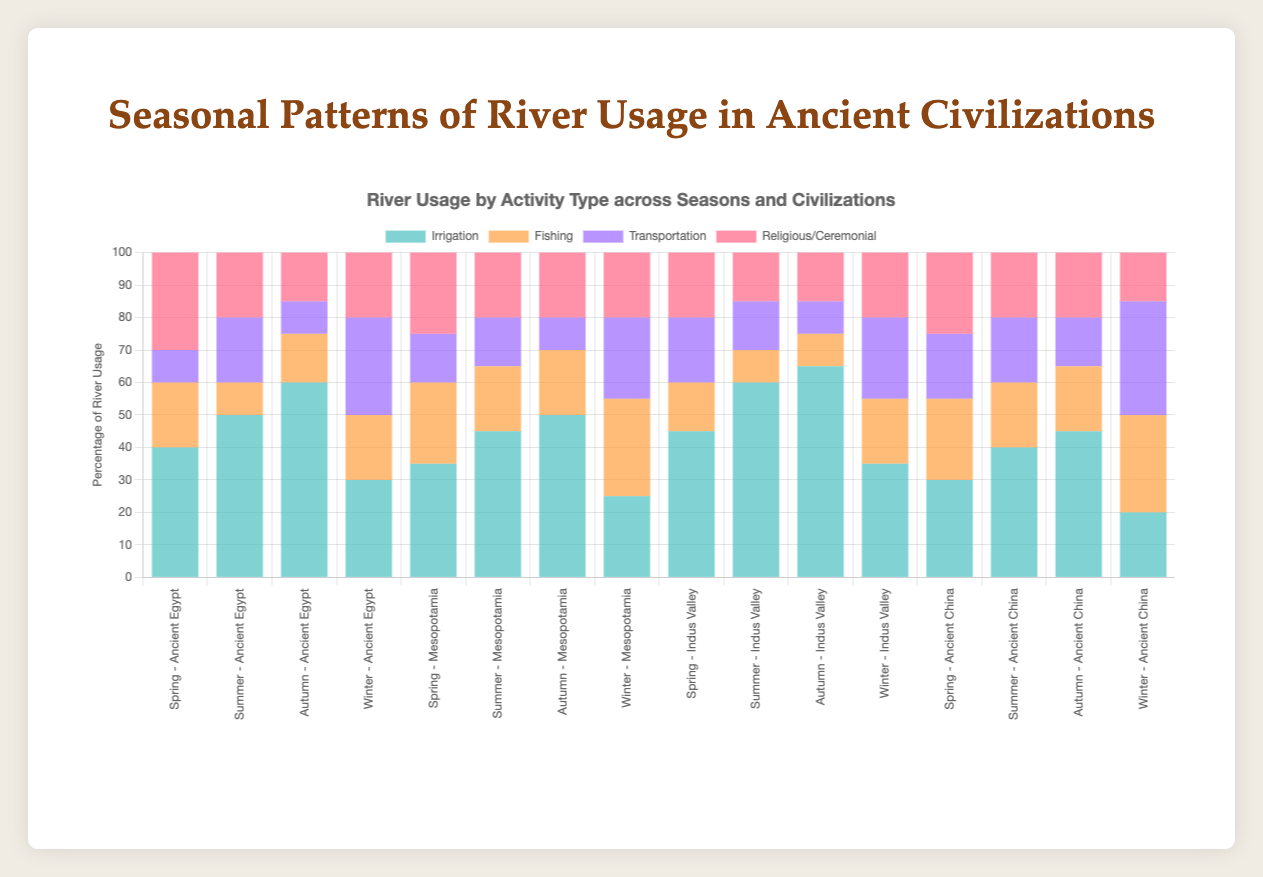What is the most common activity type for Ancient Egypt during the summer season? In the summer season, we look at the data for Ancient Egypt. The values are Irrigation 50, Fishing 10, Transportation 20, Religious/Ceremonial 20. The highest value is 50 for Irrigation.
Answer: Irrigation Compare the usage of the river for transportation between winter and spring for the Indus Valley civilization. Which season has a higher usage? Look at the transportation data for the Indus Valley civilization. For winter, it is 25, and for spring, it is 20. 25 is greater than 20, so winter has a higher usage for transportation.
Answer: Winter What is the total percentage usage of the river for the Mesopotamian civilization in the winter season? Sum the values for Mesopotamia in winter: Irrigation 25, Fishing 30, Transportation 25, Religious/Ceremonial 20. The total is 25+30+25+20 = 100.
Answer: 100 Which civilization has the highest percentage of river usage for fishing during the winter season? Compare the fishing percentages for winter across all civilizations. Ancient Egypt 20, Mesopotamia 30, Indus Valley 20, Ancient China 30. The highest values are 30 for both Mesopotamia and Ancient China.
Answer: Mesopotamia, Ancient China In the spring season, which civilization has a higher usage for religious/ceremonial activities, Mesopotamia or Ancient China? Compare the religious/ceremonial values for spring. Mesopotamia has 25 and Ancient China has 25. Since both values are equal, neither has a higher usage.
Answer: Both are equal What is the difference in the percentage of river usage for irrigation between summer and winter for Ancient China? Look at the irrigation data for Ancient China. For summer, it is 40, and for winter, it is 20. The difference is 40 - 20 = 20.
Answer: 20 What is the average percentage usage of the river for irrigation in the autumn season across all civilizations? Add the irrigation values for autumn across all civilizations, then divide by the number of civilizations. Ancient Egypt 60, Mesopotamia 50, Indus Valley 65, Ancient China 45. The total is 60+50+65+45 = 220. Dividing by 4, the average is 220/4 = 55.
Answer: 55 Which civilization utilizes the river least for transportation purposes? Compare the transportation values across all seasons for each civilization. The civilization with the smallest sum is the one that uses it the least. Ancient Egypt: 10+20+10+30=70, Mesopotamia: 15+15+10+25=65, Indus Valley: 20+15+10+25=70, Ancient China: 20+20+15+35=90. Mesopotamia has the smallest total usage for transportation.
Answer: Mesopotamia What activity has the lowest percentage usage during autumn in the Indus Valley civilization? Look at the autumn values for the Indus Valley. Irrigation 65, Fishing 10, Transportation 10, Religious/Ceremonial 15. The lowest values are for Fishing and Transportation, both at 10.
Answer: Fishing, Transportation During which season is religious/ceremonial river usage highest in Ancient Egypt? Compare the religious/ceremonial values for each season in Ancient Egypt: Spring 30, Summer 20, Autumn 15, Winter 20. The highest value is 30 in the spring.
Answer: Spring 